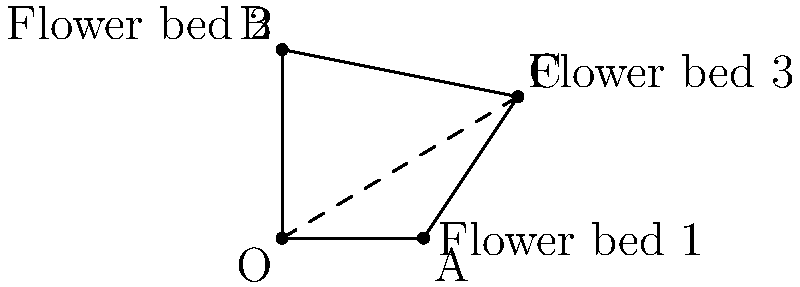You want to arrange three flower beds to maximize bee coverage. The positions of the flower beds relative to a central point O are given by vectors $\vec{OA} = 3\hat{i}$, $\vec{OB} = 4\hat{j}$, and $\vec{OC} = 5\hat{i} + 3\hat{j}$. What is the total area of the triangle formed by these three flower beds? To find the area of the triangle formed by the three flower beds, we can use the formula for the area of a triangle given two vectors:

Area = $\frac{1}{2}|\vec{v} \times \vec{w}|$

Where $\vec{v}$ and $\vec{w}$ are two vectors forming two sides of the triangle.

Step 1: Find vectors $\vec{AB}$ and $\vec{AC}$
$\vec{AB} = \vec{OB} - \vec{OA} = (0 - 3)\hat{i} + (4 - 0)\hat{j} = -3\hat{i} + 4\hat{j}$
$\vec{AC} = \vec{OC} - \vec{OA} = (5 - 3)\hat{i} + (3 - 0)\hat{j} = 2\hat{i} + 3\hat{j}$

Step 2: Calculate the cross product $\vec{AB} \times \vec{AC}$
$\vec{AB} \times \vec{AC} = (-3 \cdot 3 - 4 \cdot 2)\hat{k} = -17\hat{k}$

Step 3: Calculate the magnitude of the cross product
$|\vec{AB} \times \vec{AC}| = 17$

Step 4: Calculate the area
Area = $\frac{1}{2} \cdot 17 = 8.5$ square meters

Therefore, the total area of the triangle formed by the three flower beds is 8.5 square meters.
Answer: 8.5 m² 